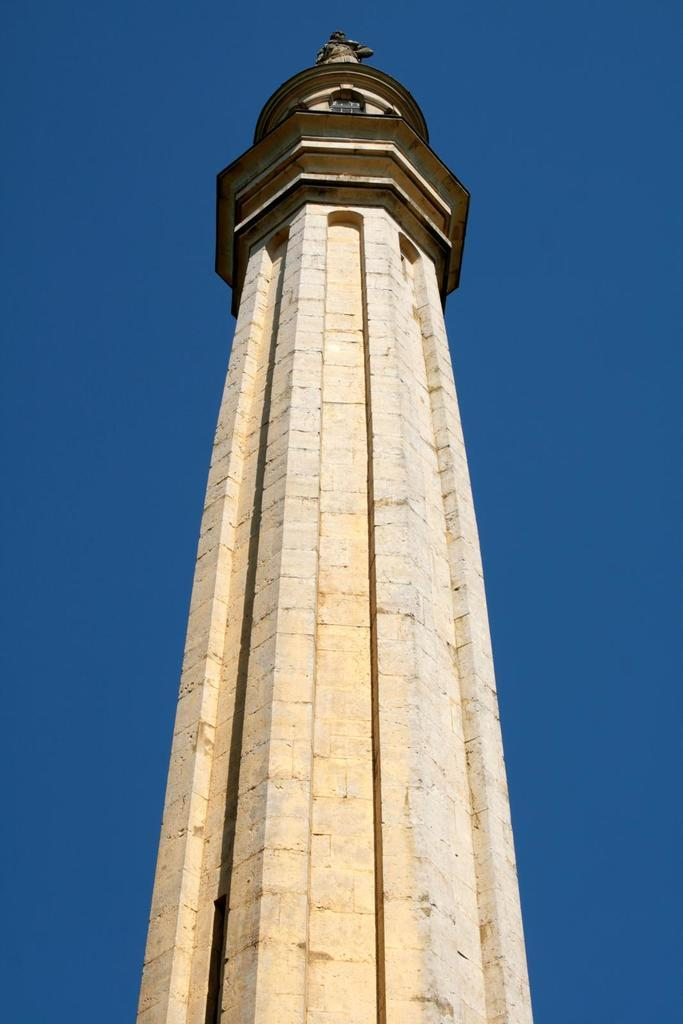What is the main structure in the image? There is a tower in the image. What can be seen in the background of the image? The sky is visible in the background of the image. What type of pets can be seen playing in the image? There are no pets or any indication of play in the image; it features a tower and the sky. 